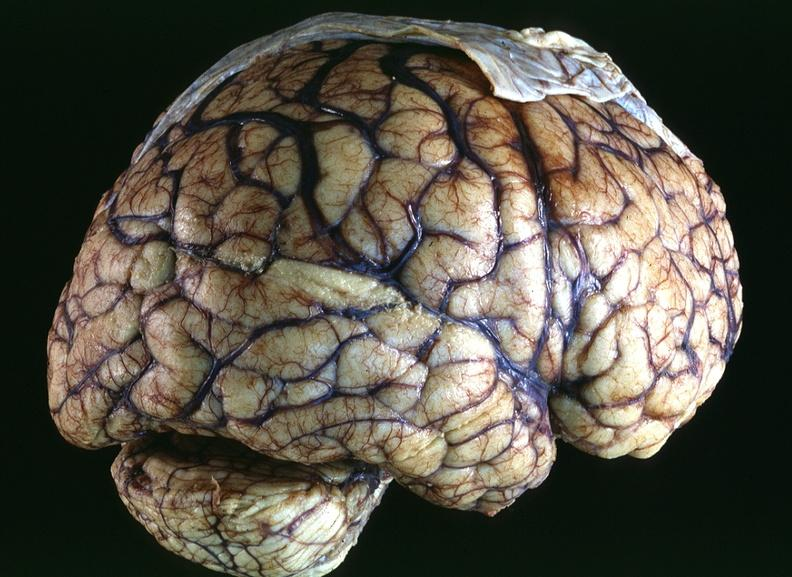what is present?
Answer the question using a single word or phrase. Nervous 